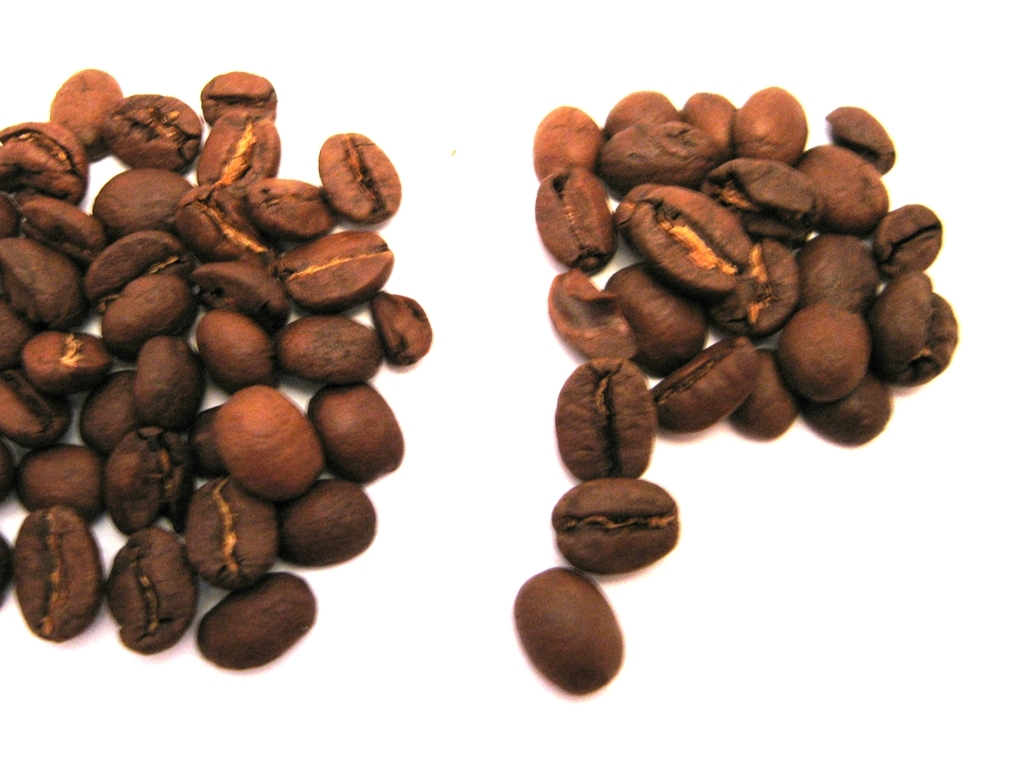Are there any color inaccuracies in this image? Based on the image provided, there don't appear to be any notable color inaccuracies. The coffee beans display the rich, dark brown tones one would expect from roasted beans, suggesting the image portrays their coloration accurately. 